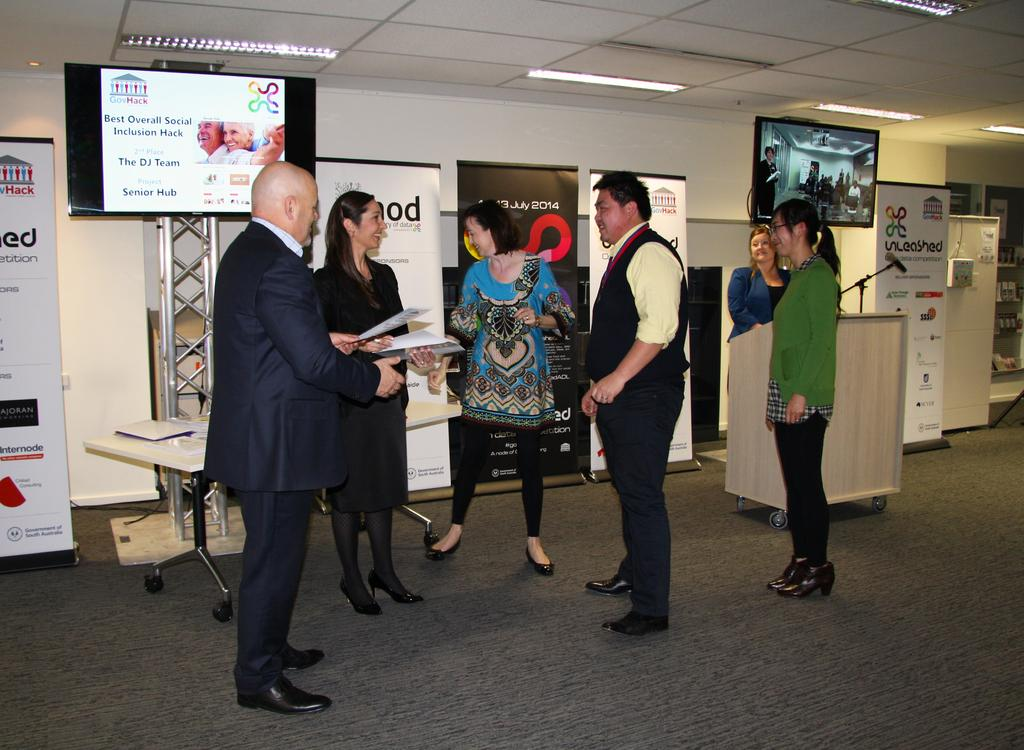What can be seen in the image? There are people standing in the image. What is visible in the background? There are posters in the background of the image, and there is a wall in the background as well. What is written on the posters? There is text on the posters. What is above the people in the image? There is a ceiling visible in the image, and there are lights on the ceiling. How many mittens are hanging on the wall in the image? There are no mittens present in the image; the wall has posters with text on them. 